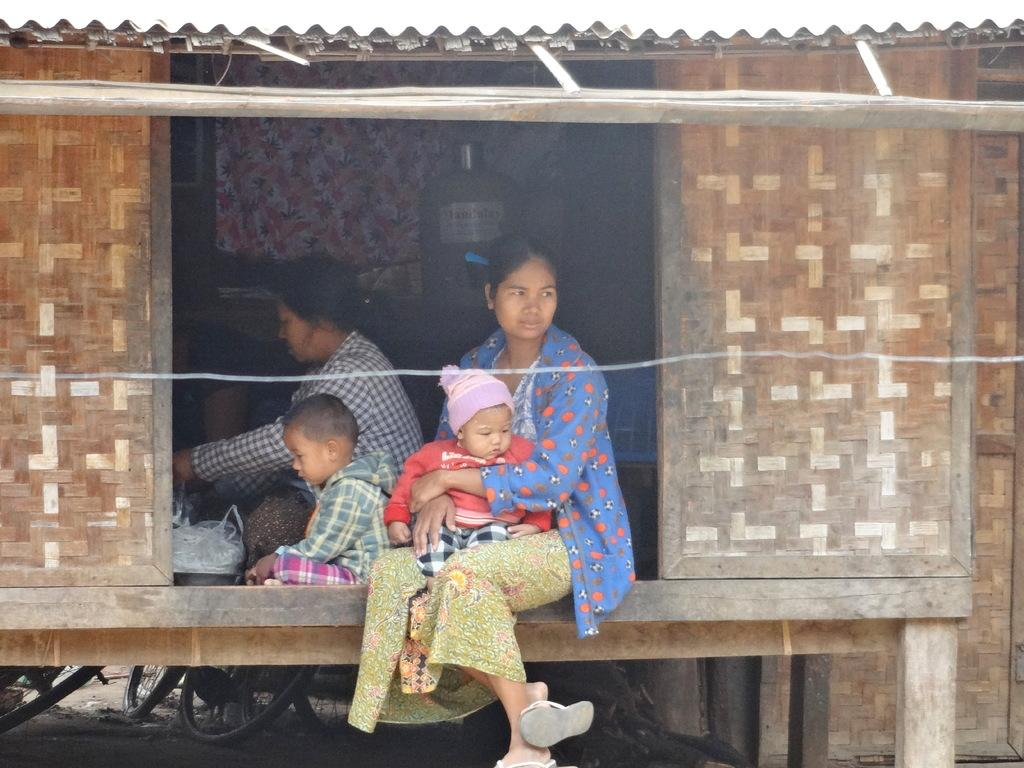What type of structure is visible in the image? There is a shed in the image. Can you describe the people in the image? There are people in the image. What tool is present in the image for watering plants? There is a water can in the image. What type of window treatment is present in the image? There is a curtain in the image. What else can be seen in the image besides the shed and people? There are objects in the image, including a water can and a curtain. What mode of transportation is visible on the ground under the shed? Bicycles are on the ground under the shed. What type of collar can be seen on the dog in the image? There is no dog present in the image, so there is no collar to be seen. 